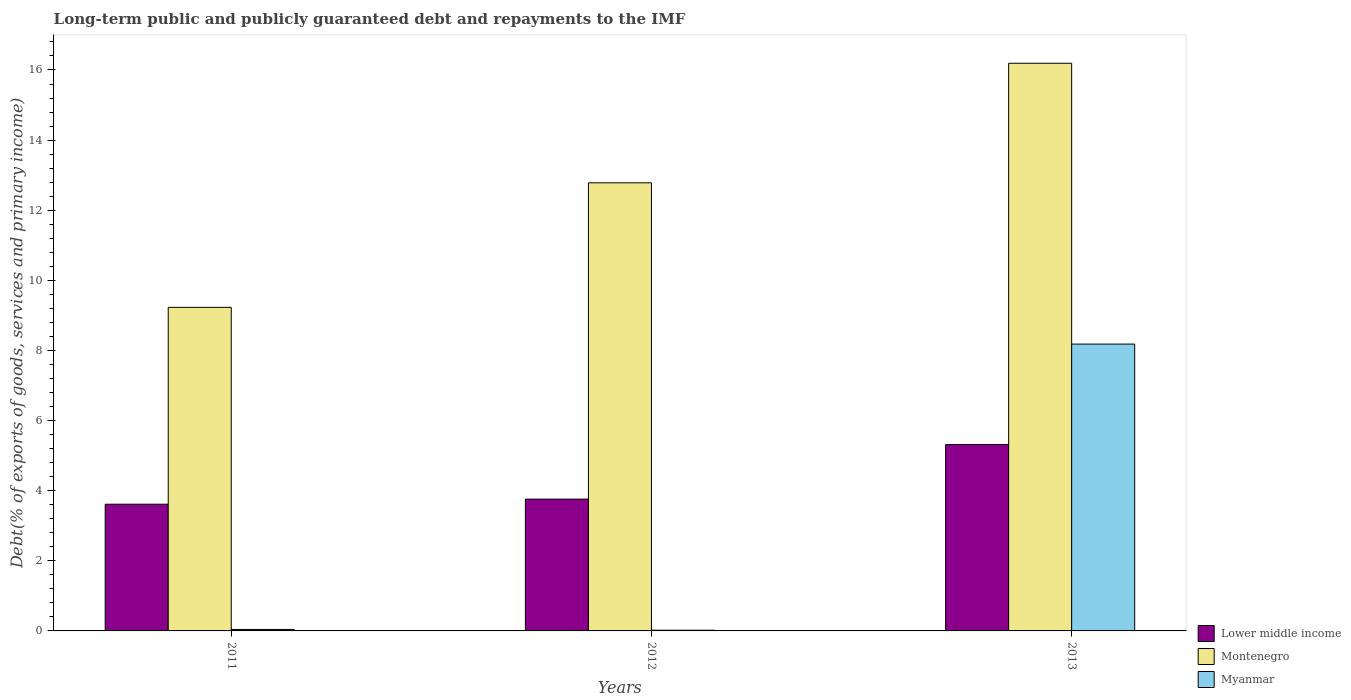How many different coloured bars are there?
Offer a very short reply. 3. How many groups of bars are there?
Ensure brevity in your answer.  3. Are the number of bars per tick equal to the number of legend labels?
Your answer should be compact. Yes. Are the number of bars on each tick of the X-axis equal?
Your answer should be very brief. Yes. What is the label of the 3rd group of bars from the left?
Your answer should be very brief. 2013. In how many cases, is the number of bars for a given year not equal to the number of legend labels?
Offer a very short reply. 0. What is the debt and repayments in Montenegro in 2011?
Your response must be concise. 9.23. Across all years, what is the maximum debt and repayments in Lower middle income?
Provide a short and direct response. 5.31. Across all years, what is the minimum debt and repayments in Montenegro?
Give a very brief answer. 9.23. What is the total debt and repayments in Myanmar in the graph?
Your answer should be very brief. 8.24. What is the difference between the debt and repayments in Montenegro in 2011 and that in 2012?
Provide a short and direct response. -3.55. What is the difference between the debt and repayments in Myanmar in 2012 and the debt and repayments in Montenegro in 2013?
Offer a very short reply. -16.17. What is the average debt and repayments in Myanmar per year?
Keep it short and to the point. 2.75. In the year 2013, what is the difference between the debt and repayments in Lower middle income and debt and repayments in Montenegro?
Ensure brevity in your answer.  -10.88. What is the ratio of the debt and repayments in Lower middle income in 2011 to that in 2012?
Give a very brief answer. 0.96. Is the debt and repayments in Myanmar in 2012 less than that in 2013?
Ensure brevity in your answer.  Yes. What is the difference between the highest and the second highest debt and repayments in Montenegro?
Your answer should be compact. 3.41. What is the difference between the highest and the lowest debt and repayments in Lower middle income?
Your answer should be very brief. 1.7. In how many years, is the debt and repayments in Lower middle income greater than the average debt and repayments in Lower middle income taken over all years?
Provide a short and direct response. 1. Is the sum of the debt and repayments in Myanmar in 2011 and 2012 greater than the maximum debt and repayments in Lower middle income across all years?
Your answer should be compact. No. What does the 2nd bar from the left in 2013 represents?
Provide a short and direct response. Montenegro. What does the 1st bar from the right in 2013 represents?
Give a very brief answer. Myanmar. Are the values on the major ticks of Y-axis written in scientific E-notation?
Make the answer very short. No. Does the graph contain any zero values?
Provide a short and direct response. No. Does the graph contain grids?
Give a very brief answer. No. Where does the legend appear in the graph?
Your answer should be compact. Bottom right. How many legend labels are there?
Your answer should be compact. 3. What is the title of the graph?
Provide a short and direct response. Long-term public and publicly guaranteed debt and repayments to the IMF. Does "Oman" appear as one of the legend labels in the graph?
Provide a short and direct response. No. What is the label or title of the X-axis?
Ensure brevity in your answer.  Years. What is the label or title of the Y-axis?
Provide a short and direct response. Debt(% of exports of goods, services and primary income). What is the Debt(% of exports of goods, services and primary income) of Lower middle income in 2011?
Keep it short and to the point. 3.61. What is the Debt(% of exports of goods, services and primary income) of Montenegro in 2011?
Your response must be concise. 9.23. What is the Debt(% of exports of goods, services and primary income) of Myanmar in 2011?
Make the answer very short. 0.04. What is the Debt(% of exports of goods, services and primary income) in Lower middle income in 2012?
Offer a terse response. 3.76. What is the Debt(% of exports of goods, services and primary income) of Montenegro in 2012?
Offer a very short reply. 12.78. What is the Debt(% of exports of goods, services and primary income) in Myanmar in 2012?
Offer a very short reply. 0.02. What is the Debt(% of exports of goods, services and primary income) in Lower middle income in 2013?
Your answer should be very brief. 5.31. What is the Debt(% of exports of goods, services and primary income) in Montenegro in 2013?
Offer a very short reply. 16.19. What is the Debt(% of exports of goods, services and primary income) in Myanmar in 2013?
Ensure brevity in your answer.  8.18. Across all years, what is the maximum Debt(% of exports of goods, services and primary income) of Lower middle income?
Provide a succinct answer. 5.31. Across all years, what is the maximum Debt(% of exports of goods, services and primary income) in Montenegro?
Make the answer very short. 16.19. Across all years, what is the maximum Debt(% of exports of goods, services and primary income) of Myanmar?
Keep it short and to the point. 8.18. Across all years, what is the minimum Debt(% of exports of goods, services and primary income) in Lower middle income?
Give a very brief answer. 3.61. Across all years, what is the minimum Debt(% of exports of goods, services and primary income) in Montenegro?
Provide a short and direct response. 9.23. Across all years, what is the minimum Debt(% of exports of goods, services and primary income) of Myanmar?
Provide a short and direct response. 0.02. What is the total Debt(% of exports of goods, services and primary income) of Lower middle income in the graph?
Provide a short and direct response. 12.69. What is the total Debt(% of exports of goods, services and primary income) of Montenegro in the graph?
Ensure brevity in your answer.  38.2. What is the total Debt(% of exports of goods, services and primary income) of Myanmar in the graph?
Offer a very short reply. 8.24. What is the difference between the Debt(% of exports of goods, services and primary income) in Lower middle income in 2011 and that in 2012?
Ensure brevity in your answer.  -0.15. What is the difference between the Debt(% of exports of goods, services and primary income) of Montenegro in 2011 and that in 2012?
Offer a terse response. -3.55. What is the difference between the Debt(% of exports of goods, services and primary income) in Myanmar in 2011 and that in 2012?
Your answer should be very brief. 0.02. What is the difference between the Debt(% of exports of goods, services and primary income) in Lower middle income in 2011 and that in 2013?
Make the answer very short. -1.7. What is the difference between the Debt(% of exports of goods, services and primary income) in Montenegro in 2011 and that in 2013?
Provide a succinct answer. -6.96. What is the difference between the Debt(% of exports of goods, services and primary income) in Myanmar in 2011 and that in 2013?
Your response must be concise. -8.14. What is the difference between the Debt(% of exports of goods, services and primary income) in Lower middle income in 2012 and that in 2013?
Offer a terse response. -1.55. What is the difference between the Debt(% of exports of goods, services and primary income) of Montenegro in 2012 and that in 2013?
Give a very brief answer. -3.41. What is the difference between the Debt(% of exports of goods, services and primary income) of Myanmar in 2012 and that in 2013?
Make the answer very short. -8.16. What is the difference between the Debt(% of exports of goods, services and primary income) of Lower middle income in 2011 and the Debt(% of exports of goods, services and primary income) of Montenegro in 2012?
Offer a very short reply. -9.17. What is the difference between the Debt(% of exports of goods, services and primary income) in Lower middle income in 2011 and the Debt(% of exports of goods, services and primary income) in Myanmar in 2012?
Keep it short and to the point. 3.59. What is the difference between the Debt(% of exports of goods, services and primary income) of Montenegro in 2011 and the Debt(% of exports of goods, services and primary income) of Myanmar in 2012?
Ensure brevity in your answer.  9.21. What is the difference between the Debt(% of exports of goods, services and primary income) of Lower middle income in 2011 and the Debt(% of exports of goods, services and primary income) of Montenegro in 2013?
Ensure brevity in your answer.  -12.58. What is the difference between the Debt(% of exports of goods, services and primary income) in Lower middle income in 2011 and the Debt(% of exports of goods, services and primary income) in Myanmar in 2013?
Give a very brief answer. -4.57. What is the difference between the Debt(% of exports of goods, services and primary income) of Montenegro in 2011 and the Debt(% of exports of goods, services and primary income) of Myanmar in 2013?
Ensure brevity in your answer.  1.05. What is the difference between the Debt(% of exports of goods, services and primary income) of Lower middle income in 2012 and the Debt(% of exports of goods, services and primary income) of Montenegro in 2013?
Make the answer very short. -12.43. What is the difference between the Debt(% of exports of goods, services and primary income) of Lower middle income in 2012 and the Debt(% of exports of goods, services and primary income) of Myanmar in 2013?
Give a very brief answer. -4.42. What is the difference between the Debt(% of exports of goods, services and primary income) of Montenegro in 2012 and the Debt(% of exports of goods, services and primary income) of Myanmar in 2013?
Give a very brief answer. 4.6. What is the average Debt(% of exports of goods, services and primary income) of Lower middle income per year?
Your response must be concise. 4.23. What is the average Debt(% of exports of goods, services and primary income) of Montenegro per year?
Give a very brief answer. 12.73. What is the average Debt(% of exports of goods, services and primary income) of Myanmar per year?
Give a very brief answer. 2.75. In the year 2011, what is the difference between the Debt(% of exports of goods, services and primary income) in Lower middle income and Debt(% of exports of goods, services and primary income) in Montenegro?
Your response must be concise. -5.62. In the year 2011, what is the difference between the Debt(% of exports of goods, services and primary income) of Lower middle income and Debt(% of exports of goods, services and primary income) of Myanmar?
Ensure brevity in your answer.  3.57. In the year 2011, what is the difference between the Debt(% of exports of goods, services and primary income) in Montenegro and Debt(% of exports of goods, services and primary income) in Myanmar?
Your answer should be very brief. 9.19. In the year 2012, what is the difference between the Debt(% of exports of goods, services and primary income) of Lower middle income and Debt(% of exports of goods, services and primary income) of Montenegro?
Your answer should be very brief. -9.02. In the year 2012, what is the difference between the Debt(% of exports of goods, services and primary income) of Lower middle income and Debt(% of exports of goods, services and primary income) of Myanmar?
Offer a very short reply. 3.74. In the year 2012, what is the difference between the Debt(% of exports of goods, services and primary income) of Montenegro and Debt(% of exports of goods, services and primary income) of Myanmar?
Your response must be concise. 12.76. In the year 2013, what is the difference between the Debt(% of exports of goods, services and primary income) in Lower middle income and Debt(% of exports of goods, services and primary income) in Montenegro?
Your answer should be compact. -10.88. In the year 2013, what is the difference between the Debt(% of exports of goods, services and primary income) of Lower middle income and Debt(% of exports of goods, services and primary income) of Myanmar?
Keep it short and to the point. -2.87. In the year 2013, what is the difference between the Debt(% of exports of goods, services and primary income) in Montenegro and Debt(% of exports of goods, services and primary income) in Myanmar?
Ensure brevity in your answer.  8.01. What is the ratio of the Debt(% of exports of goods, services and primary income) of Lower middle income in 2011 to that in 2012?
Ensure brevity in your answer.  0.96. What is the ratio of the Debt(% of exports of goods, services and primary income) of Montenegro in 2011 to that in 2012?
Your answer should be compact. 0.72. What is the ratio of the Debt(% of exports of goods, services and primary income) of Myanmar in 2011 to that in 2012?
Keep it short and to the point. 2.07. What is the ratio of the Debt(% of exports of goods, services and primary income) in Lower middle income in 2011 to that in 2013?
Your answer should be very brief. 0.68. What is the ratio of the Debt(% of exports of goods, services and primary income) in Montenegro in 2011 to that in 2013?
Provide a short and direct response. 0.57. What is the ratio of the Debt(% of exports of goods, services and primary income) of Myanmar in 2011 to that in 2013?
Provide a succinct answer. 0.01. What is the ratio of the Debt(% of exports of goods, services and primary income) in Lower middle income in 2012 to that in 2013?
Ensure brevity in your answer.  0.71. What is the ratio of the Debt(% of exports of goods, services and primary income) in Montenegro in 2012 to that in 2013?
Your answer should be very brief. 0.79. What is the ratio of the Debt(% of exports of goods, services and primary income) in Myanmar in 2012 to that in 2013?
Give a very brief answer. 0. What is the difference between the highest and the second highest Debt(% of exports of goods, services and primary income) in Lower middle income?
Your answer should be compact. 1.55. What is the difference between the highest and the second highest Debt(% of exports of goods, services and primary income) in Montenegro?
Your answer should be compact. 3.41. What is the difference between the highest and the second highest Debt(% of exports of goods, services and primary income) in Myanmar?
Your answer should be compact. 8.14. What is the difference between the highest and the lowest Debt(% of exports of goods, services and primary income) of Lower middle income?
Provide a succinct answer. 1.7. What is the difference between the highest and the lowest Debt(% of exports of goods, services and primary income) of Montenegro?
Your answer should be very brief. 6.96. What is the difference between the highest and the lowest Debt(% of exports of goods, services and primary income) of Myanmar?
Make the answer very short. 8.16. 